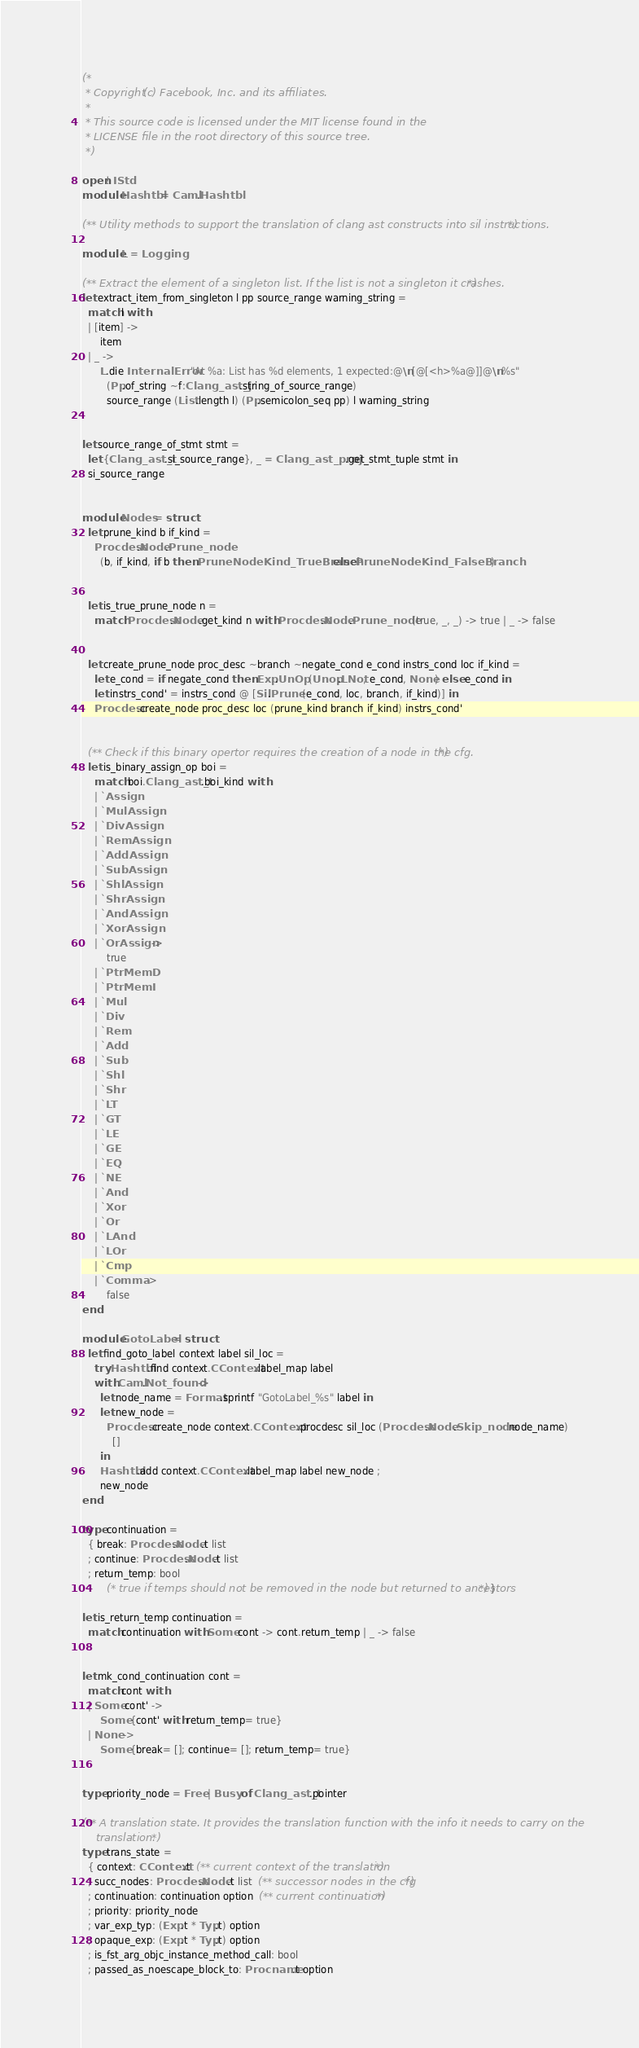<code> <loc_0><loc_0><loc_500><loc_500><_OCaml_>(*
 * Copyright (c) Facebook, Inc. and its affiliates.
 *
 * This source code is licensed under the MIT license found in the
 * LICENSE file in the root directory of this source tree.
 *)

open! IStd
module Hashtbl = Caml.Hashtbl

(** Utility methods to support the translation of clang ast constructs into sil instructions. *)

module L = Logging

(** Extract the element of a singleton list. If the list is not a singleton it crashes. *)
let extract_item_from_singleton l pp source_range warning_string =
  match l with
  | [item] ->
      item
  | _ ->
      L.die InternalError "At %a: List has %d elements, 1 expected:@\n[@[<h>%a@]]@\n%s"
        (Pp.of_string ~f:Clang_ast_j.string_of_source_range)
        source_range (List.length l) (Pp.semicolon_seq pp) l warning_string


let source_range_of_stmt stmt =
  let {Clang_ast_t.si_source_range}, _ = Clang_ast_proj.get_stmt_tuple stmt in
  si_source_range


module Nodes = struct
  let prune_kind b if_kind =
    Procdesc.Node.Prune_node
      (b, if_kind, if b then PruneNodeKind_TrueBranch else PruneNodeKind_FalseBranch)


  let is_true_prune_node n =
    match Procdesc.Node.get_kind n with Procdesc.Node.Prune_node (true, _, _) -> true | _ -> false


  let create_prune_node proc_desc ~branch ~negate_cond e_cond instrs_cond loc if_kind =
    let e_cond = if negate_cond then Exp.UnOp (Unop.LNot, e_cond, None) else e_cond in
    let instrs_cond' = instrs_cond @ [Sil.Prune (e_cond, loc, branch, if_kind)] in
    Procdesc.create_node proc_desc loc (prune_kind branch if_kind) instrs_cond'


  (** Check if this binary opertor requires the creation of a node in the cfg. *)
  let is_binary_assign_op boi =
    match boi.Clang_ast_t.boi_kind with
    | `Assign
    | `MulAssign
    | `DivAssign
    | `RemAssign
    | `AddAssign
    | `SubAssign
    | `ShlAssign
    | `ShrAssign
    | `AndAssign
    | `XorAssign
    | `OrAssign ->
        true
    | `PtrMemD
    | `PtrMemI
    | `Mul
    | `Div
    | `Rem
    | `Add
    | `Sub
    | `Shl
    | `Shr
    | `LT
    | `GT
    | `LE
    | `GE
    | `EQ
    | `NE
    | `And
    | `Xor
    | `Or
    | `LAnd
    | `LOr
    | `Cmp
    | `Comma ->
        false
end

module GotoLabel = struct
  let find_goto_label context label sil_loc =
    try Hashtbl.find context.CContext.label_map label
    with Caml.Not_found ->
      let node_name = Format.sprintf "GotoLabel_%s" label in
      let new_node =
        Procdesc.create_node context.CContext.procdesc sil_loc (Procdesc.Node.Skip_node node_name)
          []
      in
      Hashtbl.add context.CContext.label_map label new_node ;
      new_node
end

type continuation =
  { break: Procdesc.Node.t list
  ; continue: Procdesc.Node.t list
  ; return_temp: bool
        (* true if temps should not be removed in the node but returned to ancestors *) }

let is_return_temp continuation =
  match continuation with Some cont -> cont.return_temp | _ -> false


let mk_cond_continuation cont =
  match cont with
  | Some cont' ->
      Some {cont' with return_temp= true}
  | None ->
      Some {break= []; continue= []; return_temp= true}


type priority_node = Free | Busy of Clang_ast_t.pointer

(** A translation state. It provides the translation function with the info it needs to carry on the
    translation. *)
type trans_state =
  { context: CContext.t  (** current context of the translation *)
  ; succ_nodes: Procdesc.Node.t list  (** successor nodes in the cfg *)
  ; continuation: continuation option  (** current continuation *)
  ; priority: priority_node
  ; var_exp_typ: (Exp.t * Typ.t) option
  ; opaque_exp: (Exp.t * Typ.t) option
  ; is_fst_arg_objc_instance_method_call: bool
  ; passed_as_noescape_block_to: Procname.t option</code> 